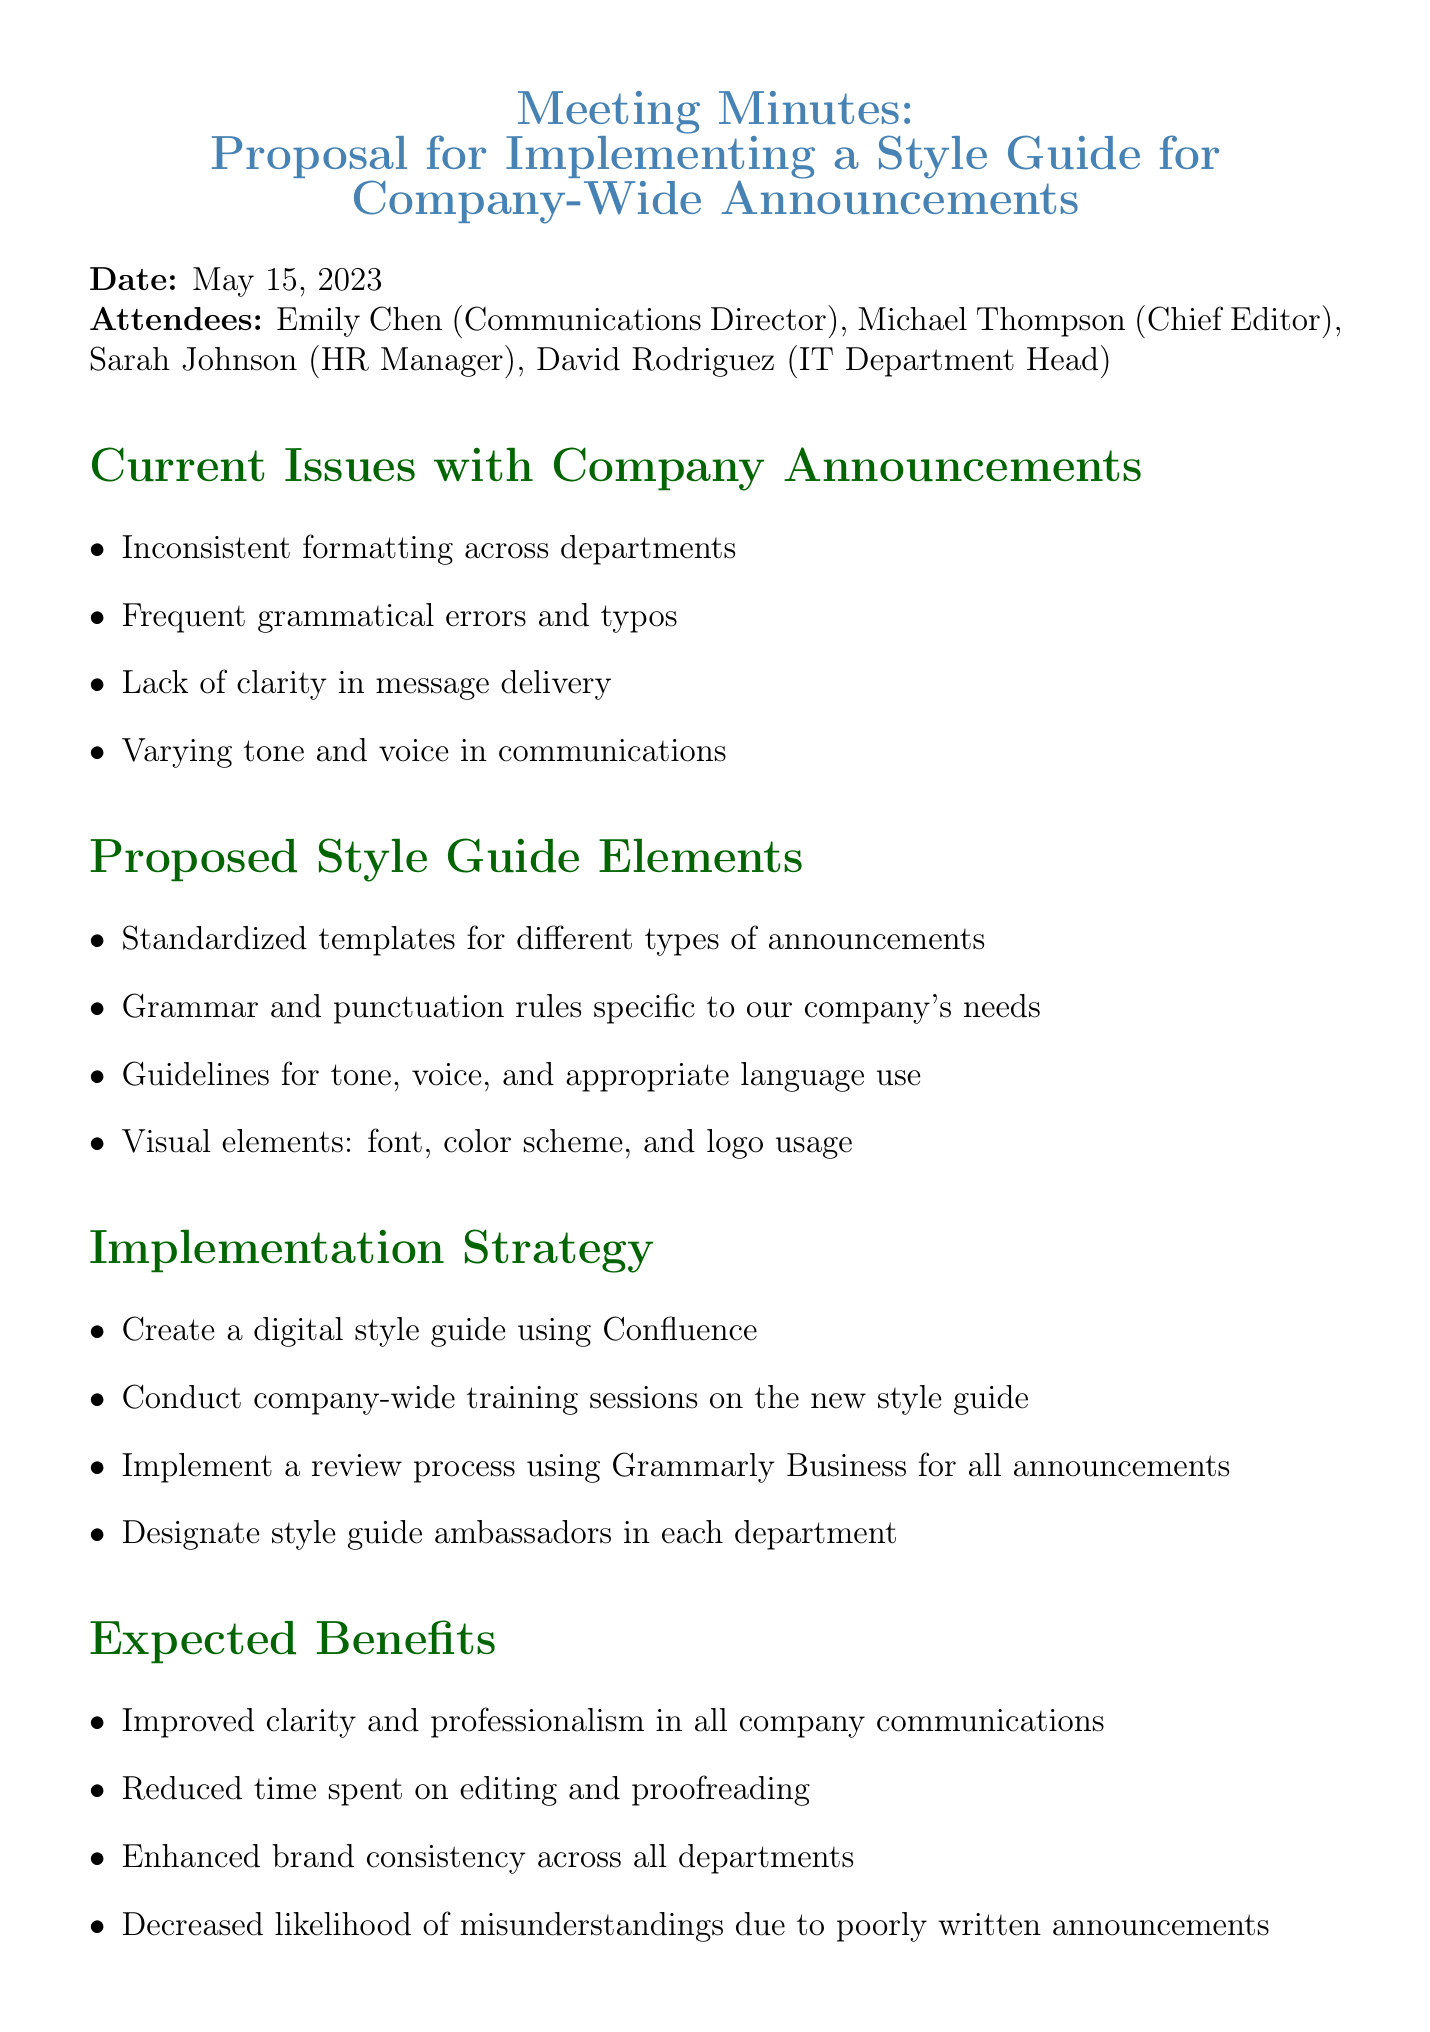What is the date of the meeting? The date of the meeting is directly stated in the document as May 15, 2023.
Answer: May 15, 2023 Who is the Communications Director? The name of the Communications Director is provided in the list of attendees.
Answer: Emily Chen What are the current issues with company announcements? The document lists several specific issues, one of which is inconsistent formatting across departments.
Answer: Inconsistent formatting across departments What is one proposed element of the style guide? The proposed style guide includes various elements, one being standardized templates for different types of announcements.
Answer: Standardized templates for different types of announcements What is the implementation strategy? The document outlines multiple strategies; one is to create a digital style guide using Confluence.
Answer: Create a digital style guide using Confluence What is one expected benefit of implementing the style guide? The document mentions several benefits, one being improved clarity and professionalism in all company communications.
Answer: Improved clarity and professionalism in all company communications What is the next step after forming a style guide committee? The document states that after forming a committee, the next step is to set a timeline for style guide development and implementation.
Answer: Set a timeline for style guide development and implementation How many attendees were present at the meeting? The document lists four attendees.
Answer: Four What tool will be used for review processes? The document specifies that Grammarly Business will be used for the review process of announcements.
Answer: Grammarly Business 